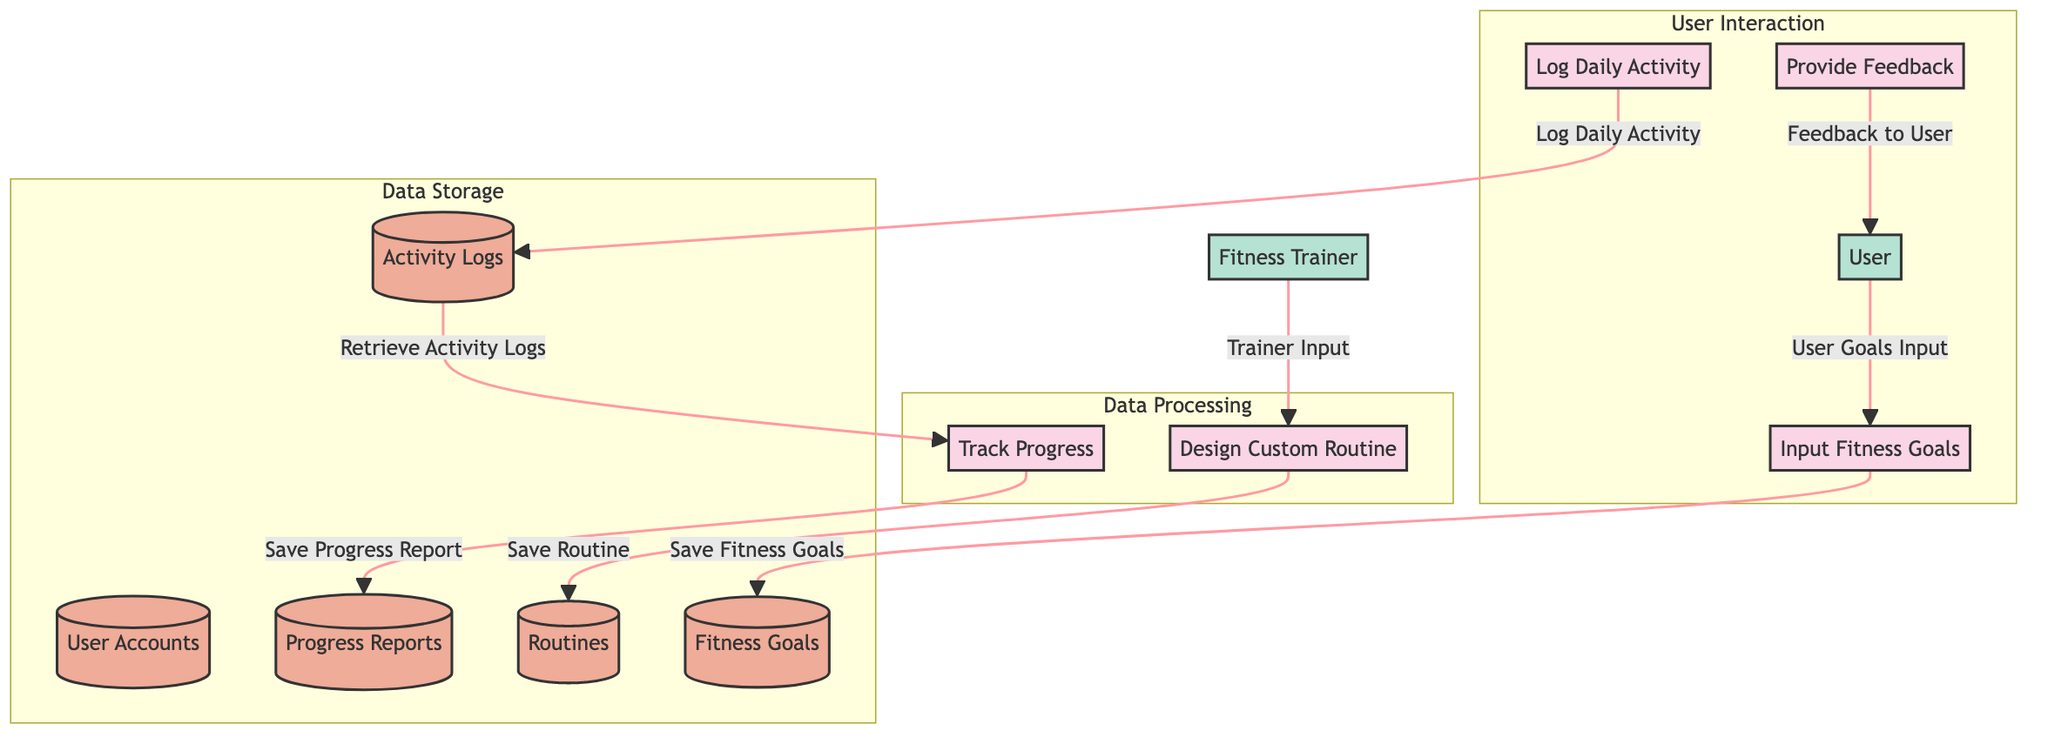What is the first process in the diagram? The diagram indicates that the first process is "Input Fitness Goals," which is represented by node P1. It is the first action initiated by the user.
Answer: Input Fitness Goals How many data stores are present in the diagram? The diagram lists five data stores: User Accounts, Fitness Goals, Routines, Activity Logs, and Progress Reports. Therefore, the total is five data stores.
Answer: 5 Which external entity provides input to the process of designing a custom routine? The diagram shows that the Fitness Trainer (EE2) provides input or modification to the "Design Custom Routine" process (P2).
Answer: Fitness Trainer What type of data does the "Activity Logs" data store hold? The "Activity Logs" data store holds daily activity logs and performance records, as specified in the description.
Answer: Daily activity logs and performance records How does the "Track Progress" process (P4) receive information? The "Track Progress" process (P4) retrieves information from the "Activity Logs" data store (DS4) by fetching activity logs, which is the only source of data for this process in the diagram.
Answer: Retrieves Activity Logs What feedback is provided to the user? The "Provide Feedback" process (P5) offers personalized feedback and adjustments to the user's routine based on their activity and progress, which is stated in the description of the process.
Answer: Personalized feedback and adjustments Which process is responsible for saving the designed routine? The process responsible for saving the designed routine is "Design Custom Routine" (P2), which stores the routine in the "Routines" data store (DS3) according to the data flow.
Answer: Design Custom Routine What action does the user perform at the start of their fitness journey? At the start of their fitness journey, the user inputs their fitness goals through the process "Input Fitness Goals" (P1), as this is the initial step in the diagram.
Answer: Inputs fitness goals 